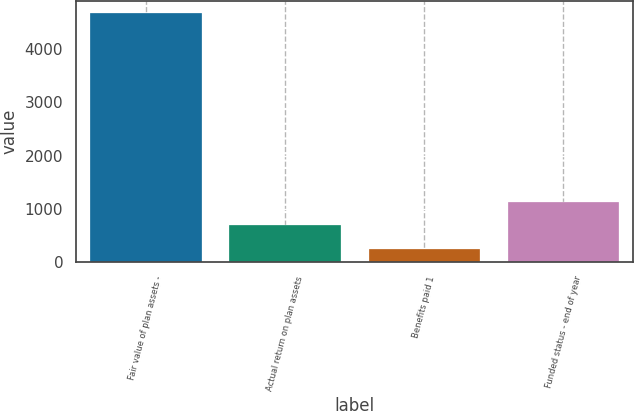Convert chart. <chart><loc_0><loc_0><loc_500><loc_500><bar_chart><fcel>Fair value of plan assets -<fcel>Actual return on plan assets<fcel>Benefits paid 1<fcel>Funded status - end of year<nl><fcel>4678<fcel>691<fcel>248<fcel>1134<nl></chart> 